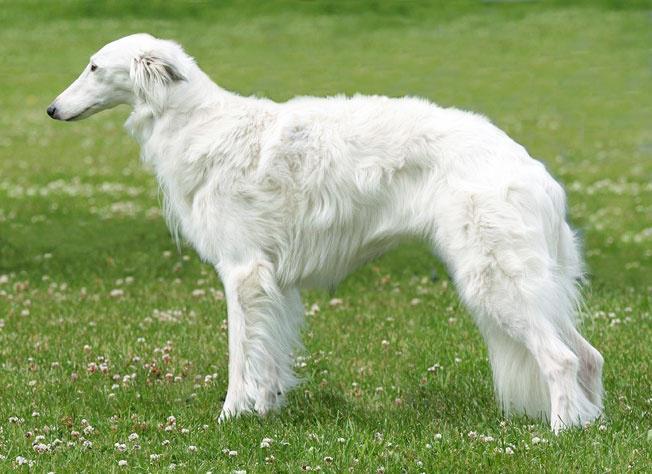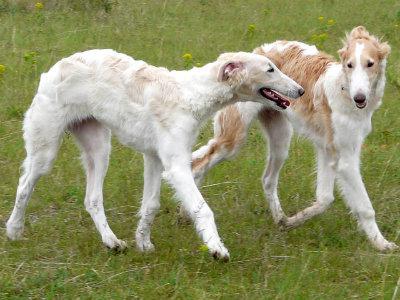The first image is the image on the left, the second image is the image on the right. Analyze the images presented: Is the assertion "Exactly three dogs are shown in grassy outdoor settings." valid? Answer yes or no. Yes. 